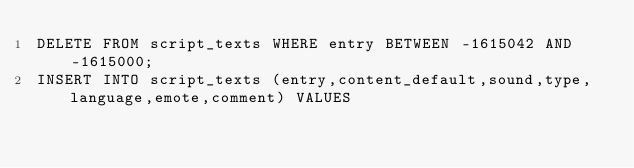<code> <loc_0><loc_0><loc_500><loc_500><_SQL_>DELETE FROM script_texts WHERE entry BETWEEN -1615042 AND -1615000;
INSERT INTO script_texts (entry,content_default,sound,type,language,emote,comment) VALUES</code> 